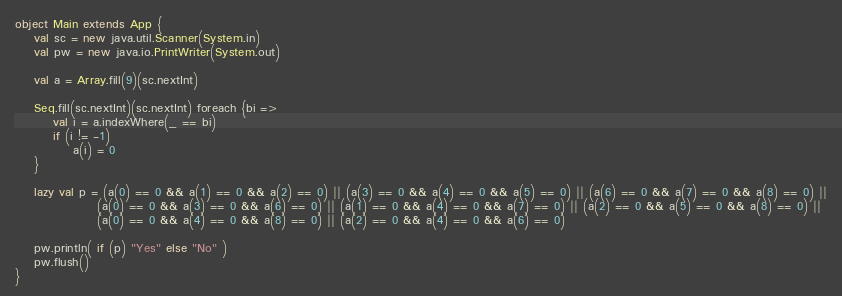Convert code to text. <code><loc_0><loc_0><loc_500><loc_500><_Scala_>object Main extends App {
	val sc = new java.util.Scanner(System.in)
	val pw = new java.io.PrintWriter(System.out)
	
	val a = Array.fill(9)(sc.nextInt)
	
	Seq.fill(sc.nextInt)(sc.nextInt) foreach {bi =>
		val i = a.indexWhere(_ == bi)
		if (i != -1)
			a(i) = 0
	}
	
	lazy val p = (a(0) == 0 && a(1) == 0 && a(2) == 0) || (a(3) == 0 && a(4) == 0 && a(5) == 0) || (a(6) == 0 && a(7) == 0 && a(8) == 0) ||
				 (a(0) == 0 && a(3) == 0 && a(6) == 0) || (a(1) == 0 && a(4) == 0 && a(7) == 0) || (a(2) == 0 && a(5) == 0 && a(8) == 0) ||
				 (a(0) == 0 && a(4) == 0 && a(8) == 0) || (a(2) == 0 && a(4) == 0 && a(6) == 0) 
	
	pw.println( if (p) "Yes" else "No" )
	pw.flush()
}</code> 